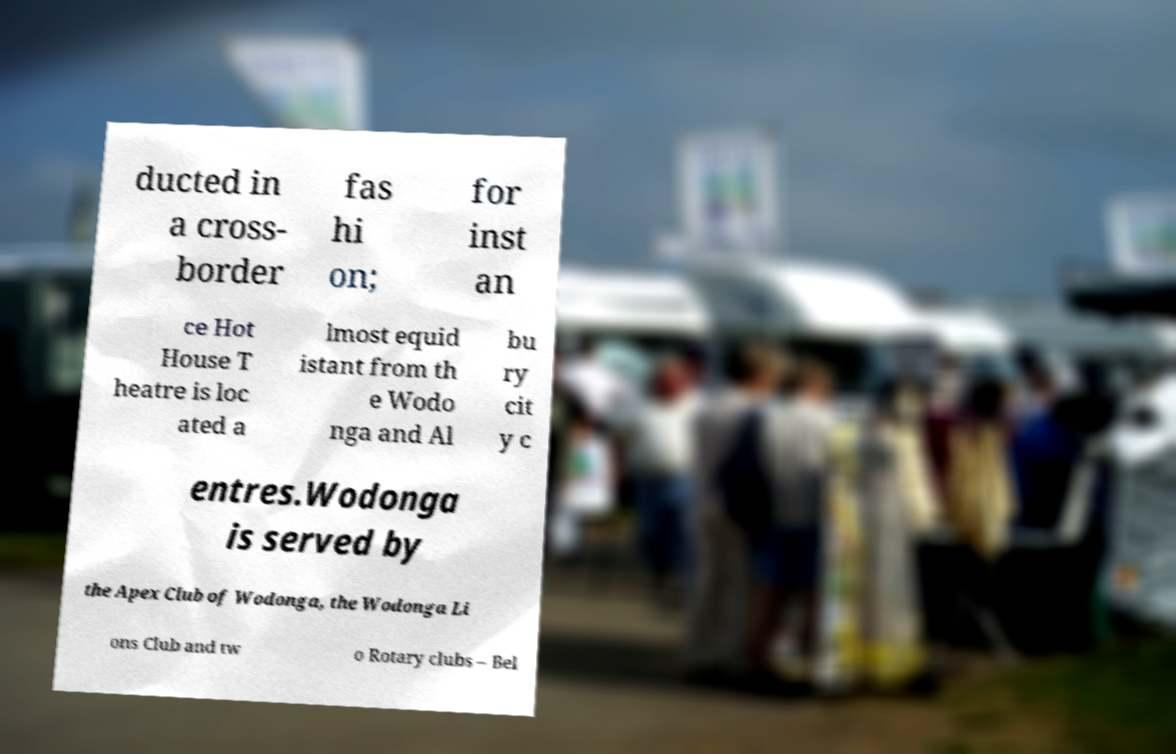Could you assist in decoding the text presented in this image and type it out clearly? ducted in a cross- border fas hi on; for inst an ce Hot House T heatre is loc ated a lmost equid istant from th e Wodo nga and Al bu ry cit y c entres.Wodonga is served by the Apex Club of Wodonga, the Wodonga Li ons Club and tw o Rotary clubs – Bel 